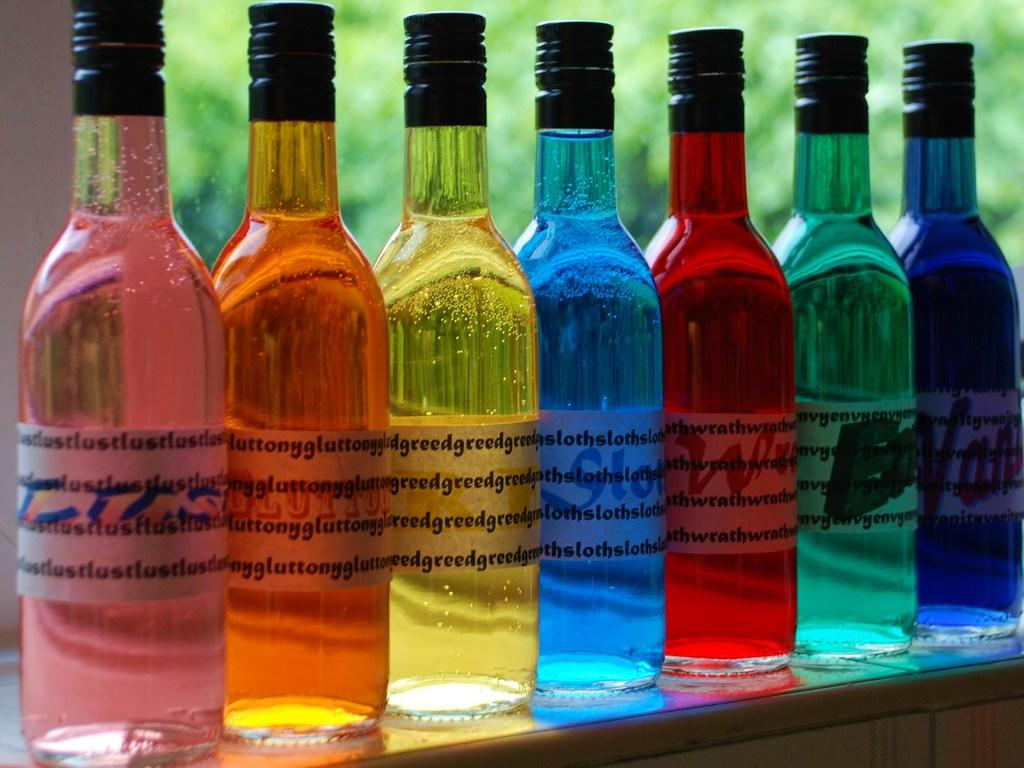<image>
Create a compact narrative representing the image presented. The yellow bottle is greed and the pink bottle is lust. 